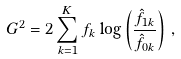Convert formula to latex. <formula><loc_0><loc_0><loc_500><loc_500>G ^ { 2 } = 2 \sum _ { k = 1 } ^ { K } f _ { k } \log \left ( \frac { \hat { f } _ { 1 k } } { \hat { f } _ { 0 k } } \right ) \, ,</formula> 